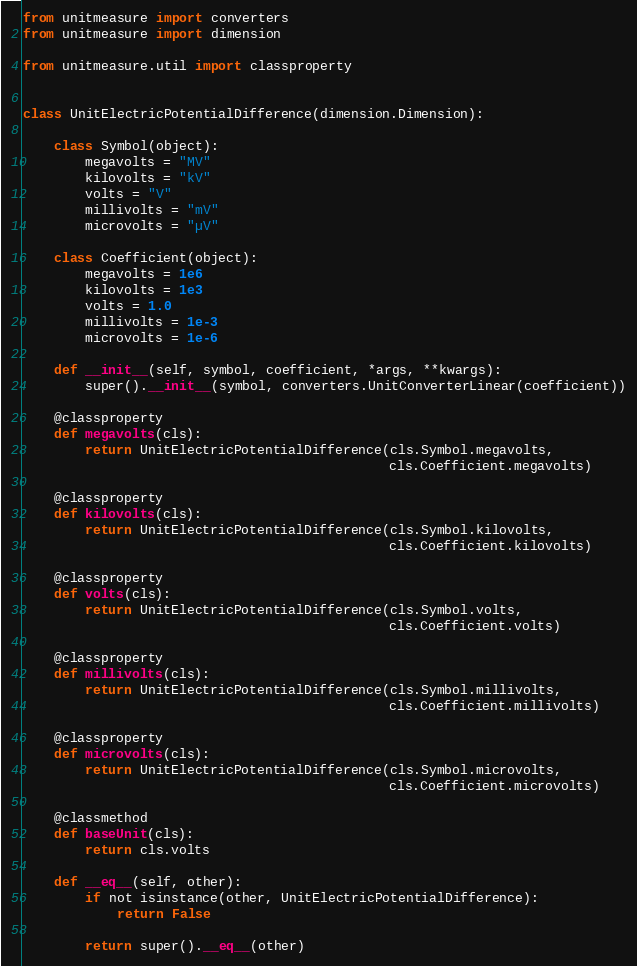<code> <loc_0><loc_0><loc_500><loc_500><_Python_>from unitmeasure import converters
from unitmeasure import dimension

from unitmeasure.util import classproperty


class UnitElectricPotentialDifference(dimension.Dimension):

    class Symbol(object):
        megavolts = "MV"
        kilovolts = "kV"
        volts = "V"
        millivolts = "mV"
        microvolts = "µV"

    class Coefficient(object):
        megavolts = 1e6
        kilovolts = 1e3
        volts = 1.0
        millivolts = 1e-3
        microvolts = 1e-6

    def __init__(self, symbol, coefficient, *args, **kwargs):
        super().__init__(symbol, converters.UnitConverterLinear(coefficient))

    @classproperty
    def megavolts(cls):
        return UnitElectricPotentialDifference(cls.Symbol.megavolts,
                                               cls.Coefficient.megavolts)

    @classproperty
    def kilovolts(cls):
        return UnitElectricPotentialDifference(cls.Symbol.kilovolts,
                                               cls.Coefficient.kilovolts)

    @classproperty
    def volts(cls):
        return UnitElectricPotentialDifference(cls.Symbol.volts,
                                               cls.Coefficient.volts)

    @classproperty
    def millivolts(cls):
        return UnitElectricPotentialDifference(cls.Symbol.millivolts,
                                               cls.Coefficient.millivolts)

    @classproperty
    def microvolts(cls):
        return UnitElectricPotentialDifference(cls.Symbol.microvolts,
                                               cls.Coefficient.microvolts)

    @classmethod
    def baseUnit(cls):
        return cls.volts

    def __eq__(self, other):
        if not isinstance(other, UnitElectricPotentialDifference):
            return False

        return super().__eq__(other)
</code> 